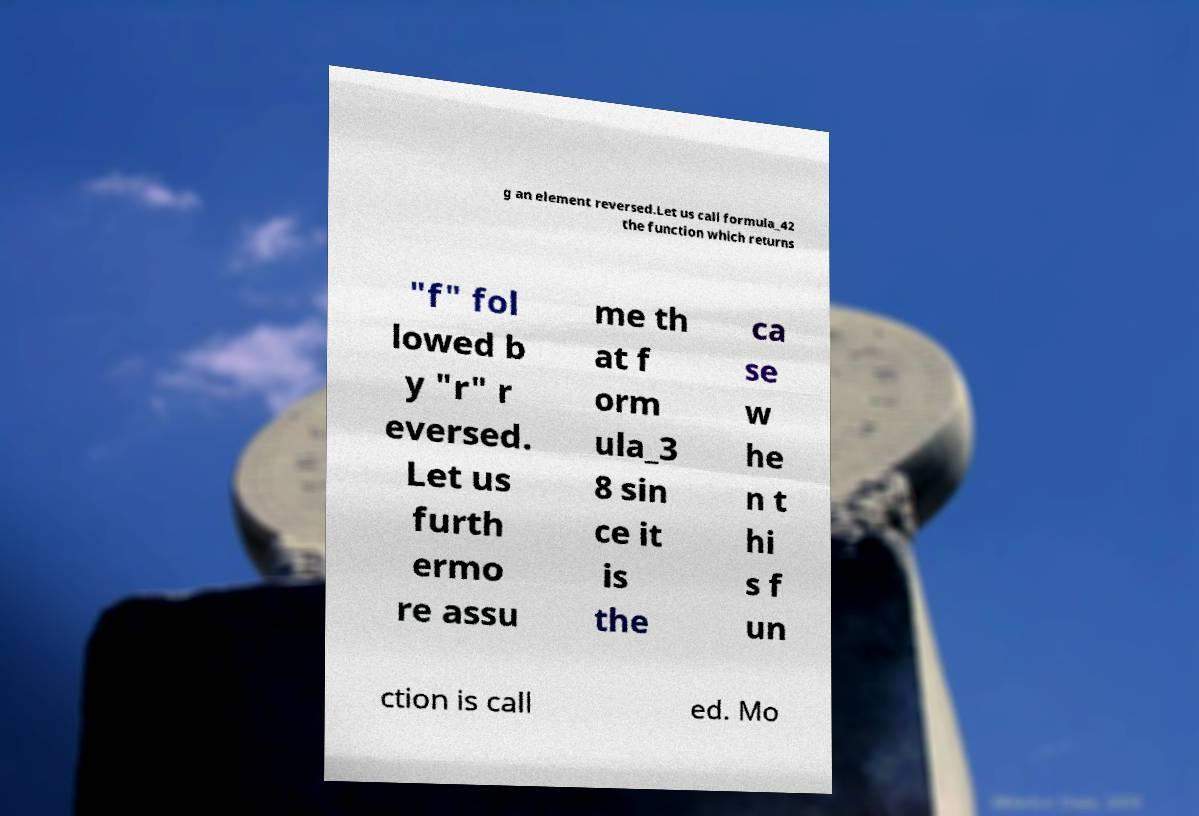Could you extract and type out the text from this image? g an element reversed.Let us call formula_42 the function which returns "f" fol lowed b y "r" r eversed. Let us furth ermo re assu me th at f orm ula_3 8 sin ce it is the ca se w he n t hi s f un ction is call ed. Mo 